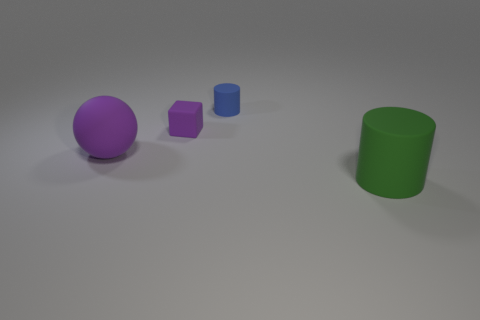Add 4 large green cylinders. How many objects exist? 8 Subtract 2 cylinders. How many cylinders are left? 0 Subtract all rubber blocks. Subtract all blue cylinders. How many objects are left? 2 Add 4 large green objects. How many large green objects are left? 5 Add 4 big shiny cylinders. How many big shiny cylinders exist? 4 Subtract all green cylinders. How many cylinders are left? 1 Subtract 0 yellow cylinders. How many objects are left? 4 Subtract all spheres. How many objects are left? 3 Subtract all brown cubes. Subtract all yellow spheres. How many cubes are left? 1 Subtract all cyan balls. How many green cylinders are left? 1 